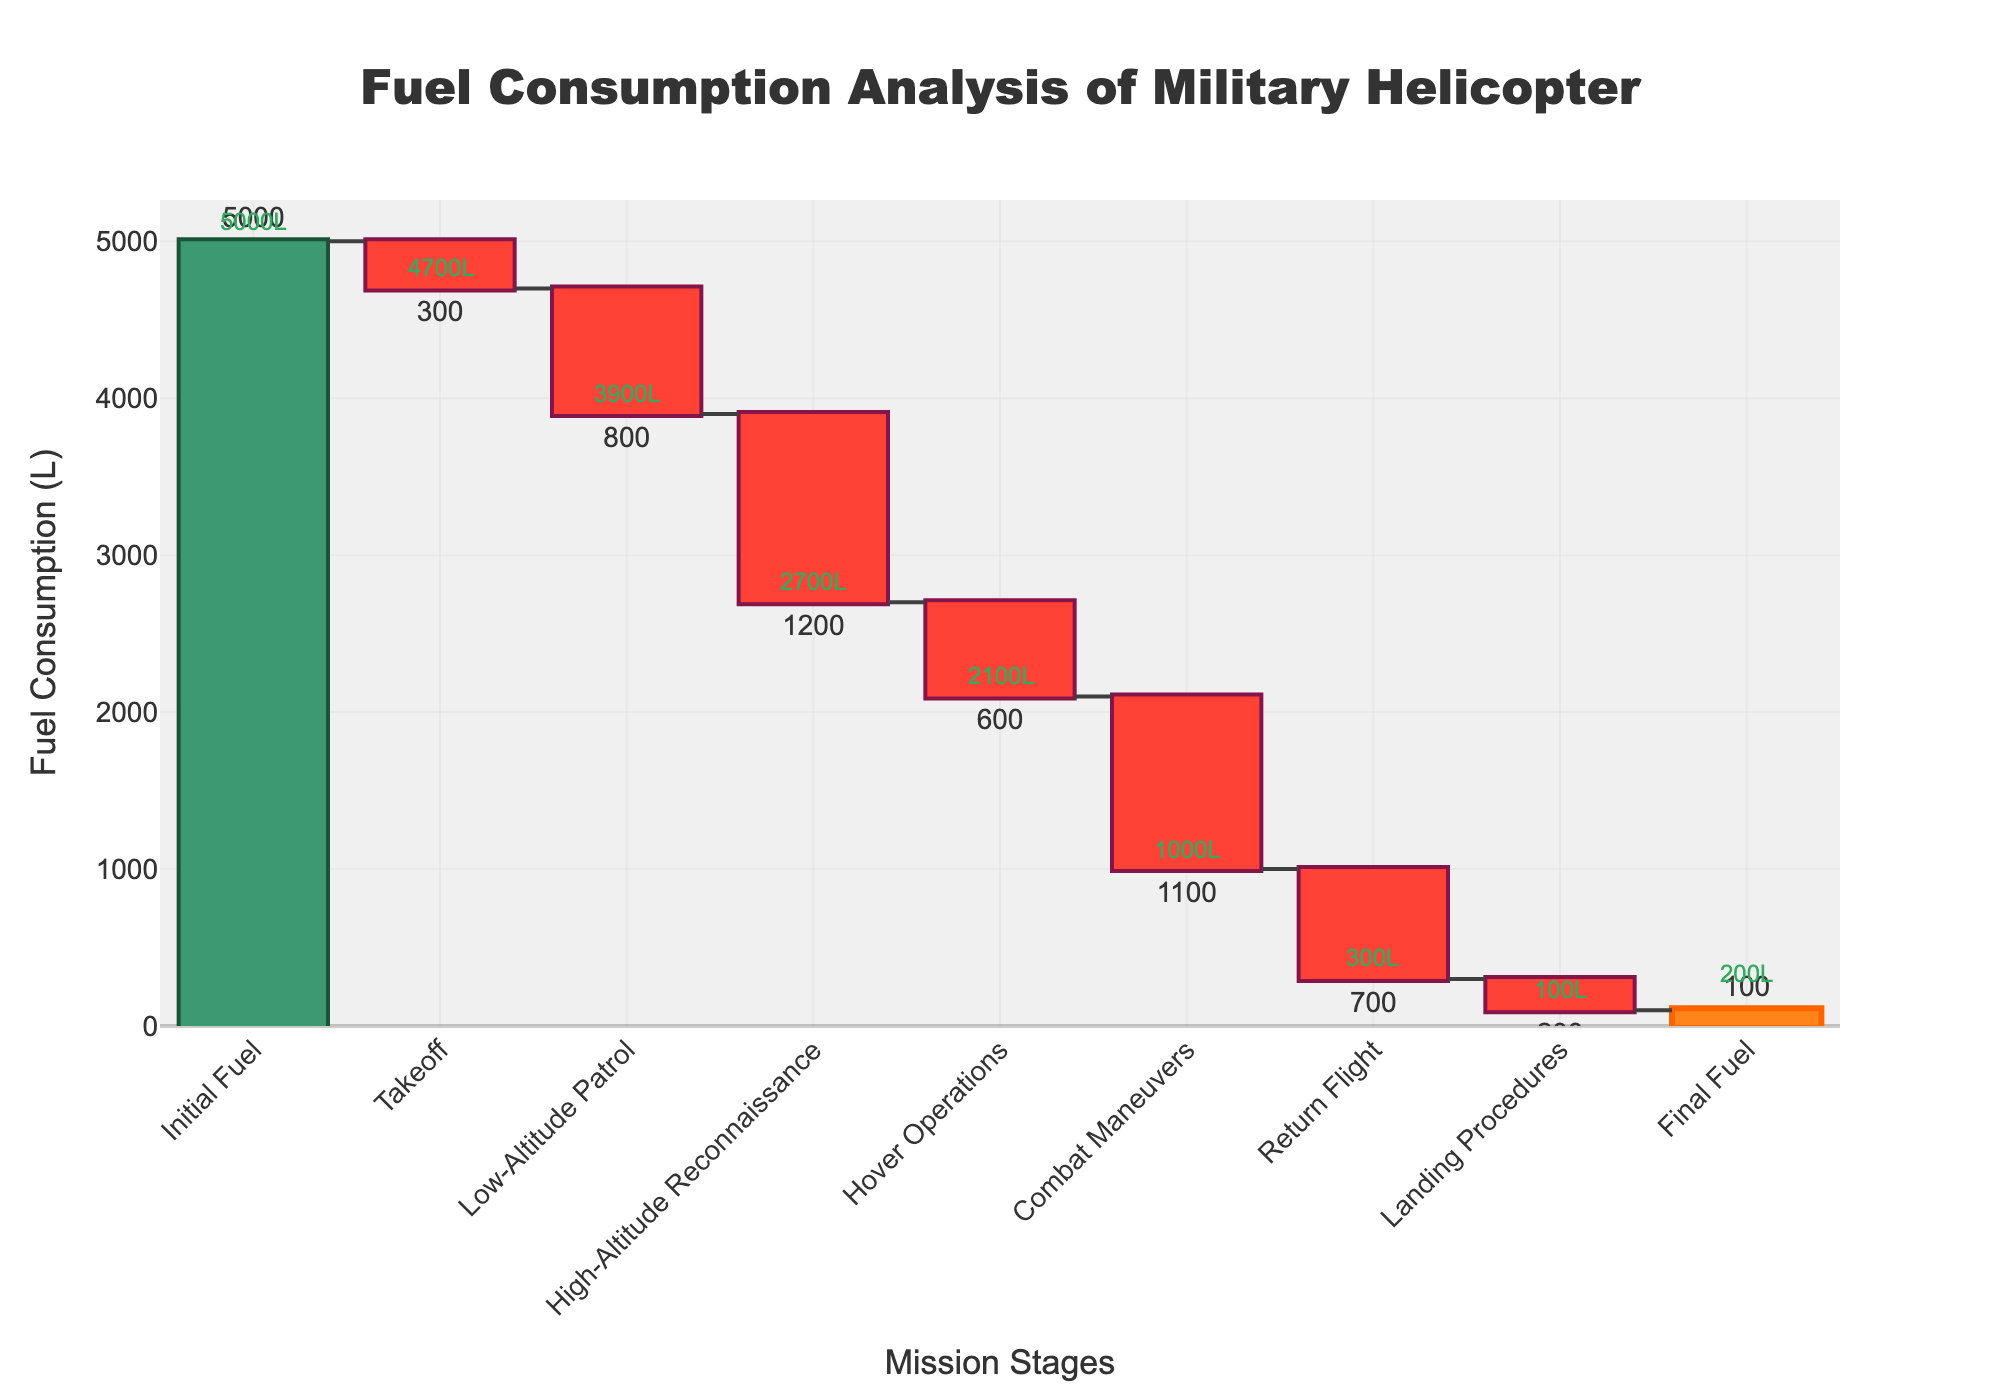What is the title of the Waterfall Chart? The title of the chart is positioned at the top center and should be the most prominent text in the figure.
Answer: Fuel Consumption Analysis of Military Helicopter How much fuel is consumed during Combat Maneuvers? The Combat Maneuvers stage corresponds to a downward bar, and the figure next to this bar is 1100, indicating fuel consumption.
Answer: 1100 liters What is the initial fuel level of the helicopter? The initial fuel level is represented by the first bar which is labeled "Initial Fuel" on the x-axis.
Answer: 5000 liters How much fuel is left after High-Altitude Reconnaissance? After the High-Altitude Reconnaissance stage, locate the cumulative fuel annotation near its bar. It shows the remaining fuel.
Answer: 2700 liters Which stage consumes the most fuel, and how much is it? Compare the length of each downward bar and check the corresponding fuel consumption labels. The longest downward bar with the largest negative value is for High-Altitude Reconnaissance.
Answer: High-Altitude Reconnaissance, 1200 liters What is the net change in fuel from the initial to the final stage? The final fuel is 100 liters, start from 5000 liters. Calculate the net change using 5000 - 100.
Answer: 4900 liters What is the total fuel consumption during all stages? Sum up all the negative values representing fuel consumption stages: 300 + 800 + 1200 + 600 + 1100 + 700 + 200.
Answer: 4900 liters During which stage does the helicopter consume the second-highest fuel? Find the second longest downward bar in the chart. The stage corresponding to it is Low-Altitude Patrol, annotated with a fuel consumption of 800 liters.
Answer: Low-Altitude Patrol How much fuel is cumulatively left after Hover Operations? The cumulative fuel left after Hover Operations can be found by referring to the annotation near that stage showing the cumulative sum up to that point.
Answer: 2000 liters What are the color differences between increasing, decreasing, and total fuel bars? Increasing bars use green, decreasing bars use red, and the total bar uses an orange color as per the annotations in the chart.
Answer: Green, Red, Orange 